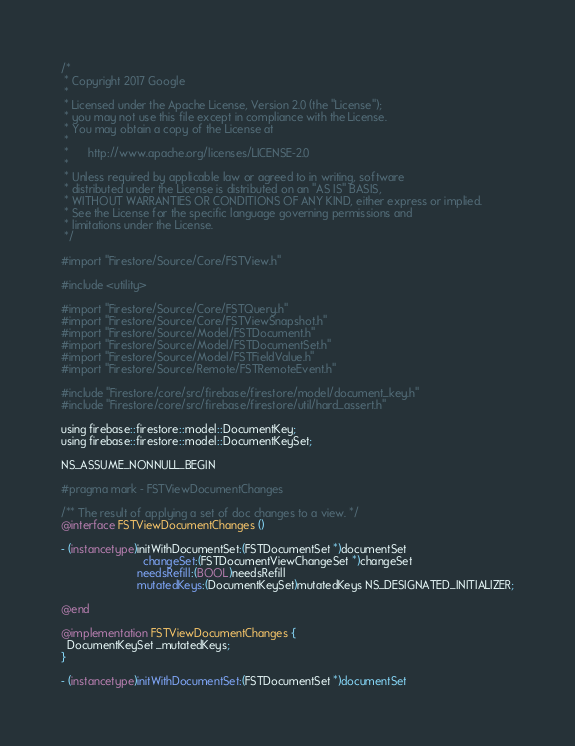<code> <loc_0><loc_0><loc_500><loc_500><_ObjectiveC_>/*
 * Copyright 2017 Google
 *
 * Licensed under the Apache License, Version 2.0 (the "License");
 * you may not use this file except in compliance with the License.
 * You may obtain a copy of the License at
 *
 *      http://www.apache.org/licenses/LICENSE-2.0
 *
 * Unless required by applicable law or agreed to in writing, software
 * distributed under the License is distributed on an "AS IS" BASIS,
 * WITHOUT WARRANTIES OR CONDITIONS OF ANY KIND, either express or implied.
 * See the License for the specific language governing permissions and
 * limitations under the License.
 */

#import "Firestore/Source/Core/FSTView.h"

#include <utility>

#import "Firestore/Source/Core/FSTQuery.h"
#import "Firestore/Source/Core/FSTViewSnapshot.h"
#import "Firestore/Source/Model/FSTDocument.h"
#import "Firestore/Source/Model/FSTDocumentSet.h"
#import "Firestore/Source/Model/FSTFieldValue.h"
#import "Firestore/Source/Remote/FSTRemoteEvent.h"

#include "Firestore/core/src/firebase/firestore/model/document_key.h"
#include "Firestore/core/src/firebase/firestore/util/hard_assert.h"

using firebase::firestore::model::DocumentKey;
using firebase::firestore::model::DocumentKeySet;

NS_ASSUME_NONNULL_BEGIN

#pragma mark - FSTViewDocumentChanges

/** The result of applying a set of doc changes to a view. */
@interface FSTViewDocumentChanges ()

- (instancetype)initWithDocumentSet:(FSTDocumentSet *)documentSet
                          changeSet:(FSTDocumentViewChangeSet *)changeSet
                        needsRefill:(BOOL)needsRefill
                        mutatedKeys:(DocumentKeySet)mutatedKeys NS_DESIGNATED_INITIALIZER;

@end

@implementation FSTViewDocumentChanges {
  DocumentKeySet _mutatedKeys;
}

- (instancetype)initWithDocumentSet:(FSTDocumentSet *)documentSet</code> 